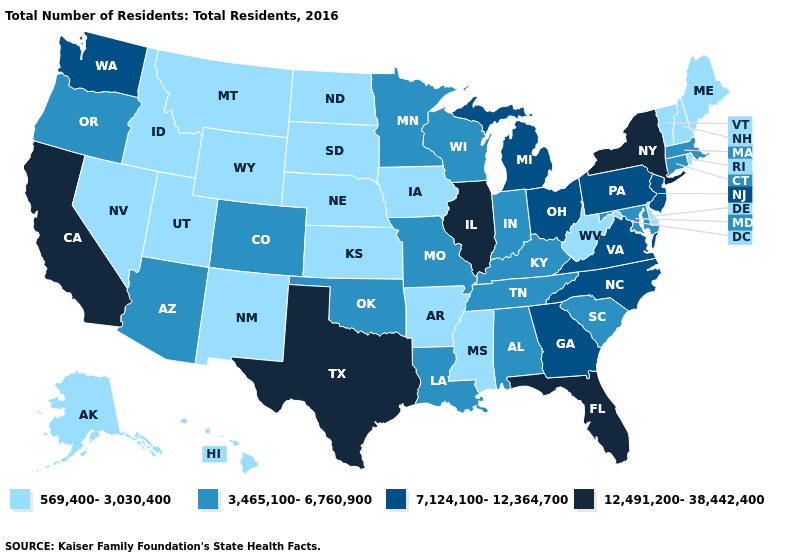Is the legend a continuous bar?
Short answer required. No. What is the value of Oregon?
Be succinct. 3,465,100-6,760,900. Which states have the highest value in the USA?
Concise answer only. California, Florida, Illinois, New York, Texas. Does Kentucky have the highest value in the USA?
Short answer required. No. Name the states that have a value in the range 3,465,100-6,760,900?
Give a very brief answer. Alabama, Arizona, Colorado, Connecticut, Indiana, Kentucky, Louisiana, Maryland, Massachusetts, Minnesota, Missouri, Oklahoma, Oregon, South Carolina, Tennessee, Wisconsin. What is the lowest value in states that border Washington?
Answer briefly. 569,400-3,030,400. What is the value of Wyoming?
Quick response, please. 569,400-3,030,400. What is the value of Kansas?
Write a very short answer. 569,400-3,030,400. What is the value of Hawaii?
Be succinct. 569,400-3,030,400. What is the value of Washington?
Keep it brief. 7,124,100-12,364,700. What is the value of Texas?
Keep it brief. 12,491,200-38,442,400. Does Oregon have the lowest value in the West?
Write a very short answer. No. Name the states that have a value in the range 3,465,100-6,760,900?
Quick response, please. Alabama, Arizona, Colorado, Connecticut, Indiana, Kentucky, Louisiana, Maryland, Massachusetts, Minnesota, Missouri, Oklahoma, Oregon, South Carolina, Tennessee, Wisconsin. Name the states that have a value in the range 12,491,200-38,442,400?
Short answer required. California, Florida, Illinois, New York, Texas. What is the value of Nevada?
Keep it brief. 569,400-3,030,400. 